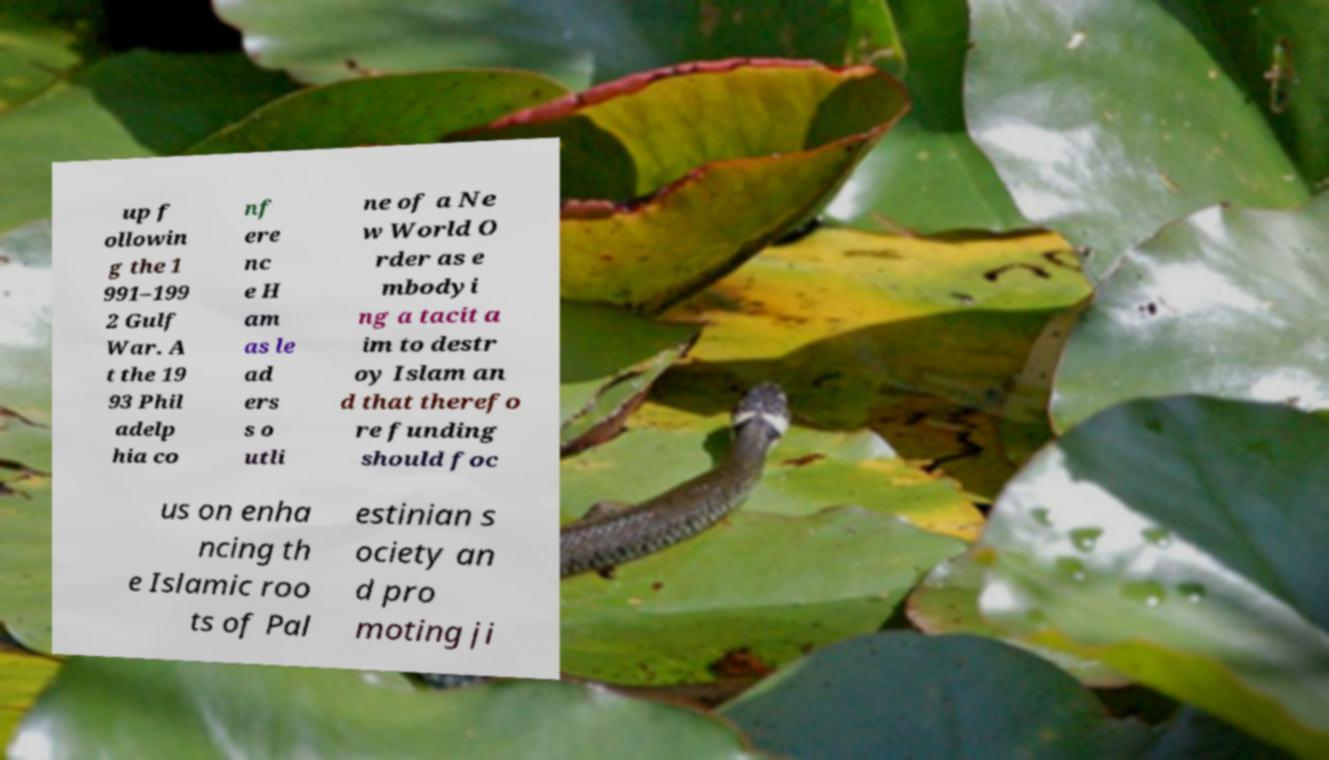For documentation purposes, I need the text within this image transcribed. Could you provide that? up f ollowin g the 1 991–199 2 Gulf War. A t the 19 93 Phil adelp hia co nf ere nc e H am as le ad ers s o utli ne of a Ne w World O rder as e mbodyi ng a tacit a im to destr oy Islam an d that therefo re funding should foc us on enha ncing th e Islamic roo ts of Pal estinian s ociety an d pro moting ji 